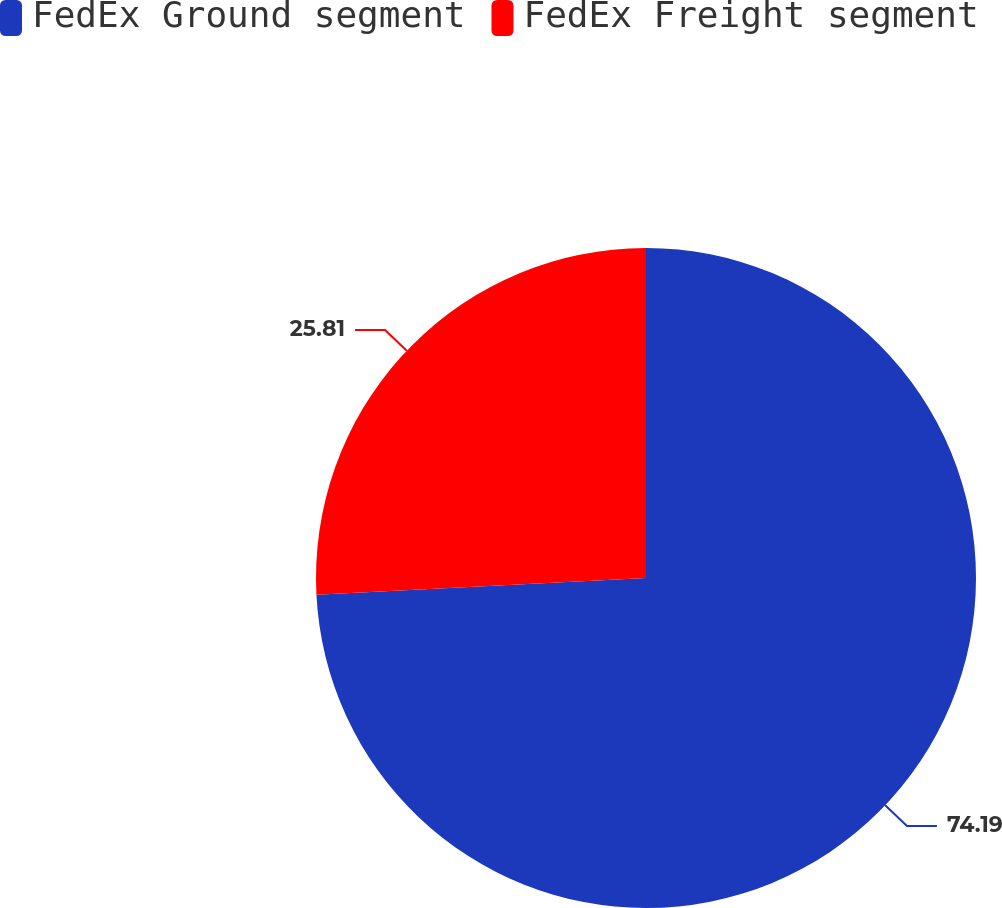Convert chart. <chart><loc_0><loc_0><loc_500><loc_500><pie_chart><fcel>FedEx Ground segment<fcel>FedEx Freight segment<nl><fcel>74.19%<fcel>25.81%<nl></chart> 